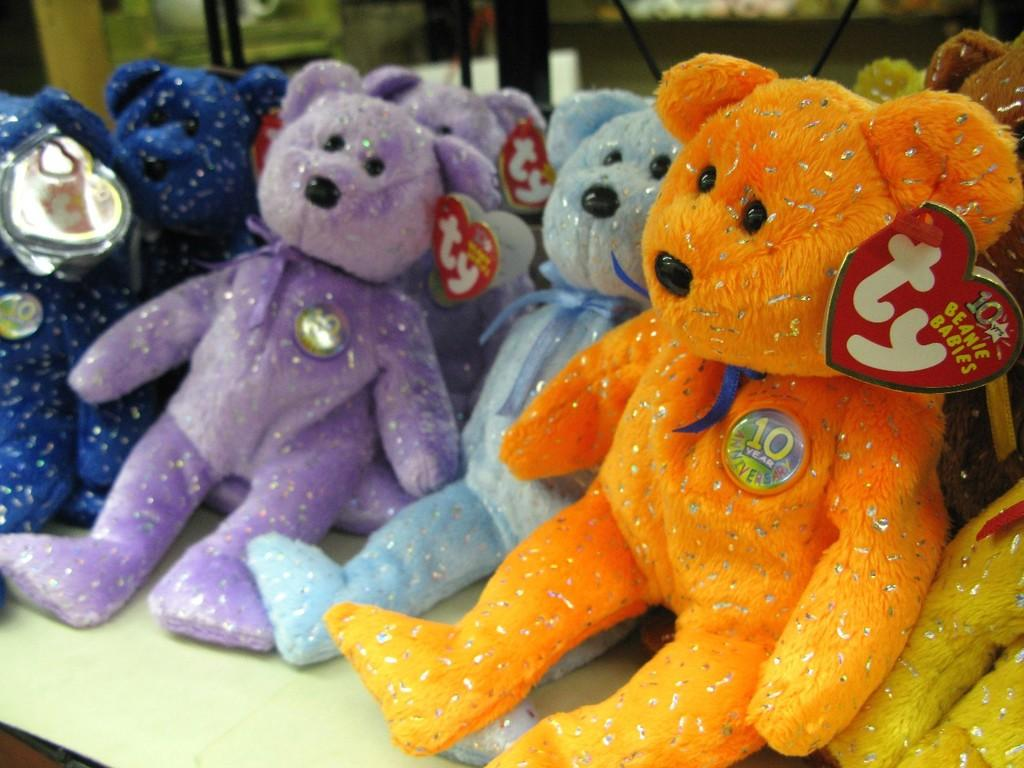What type of stuffed animals are in the image? There are teddy bears in the image. Can you describe the appearance of the teddy bears? The provided facts do not include a description of the teddy bears' appearance. Are the teddy bears arranged in a specific way in the image? The provided facts do not include information about the arrangement of the teddy bears. What type of border is present around the teddy bears in the image? There is no border present in the image; it only features teddy bears. 